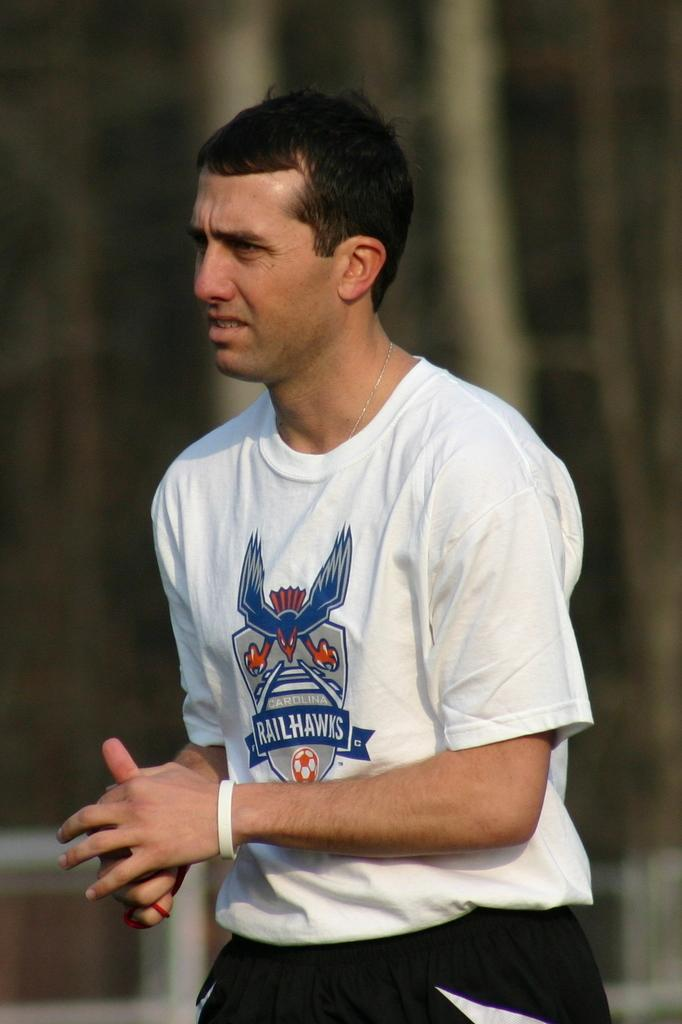<image>
Present a compact description of the photo's key features. A guy is wearing a shirt with Railhawks on the front. 